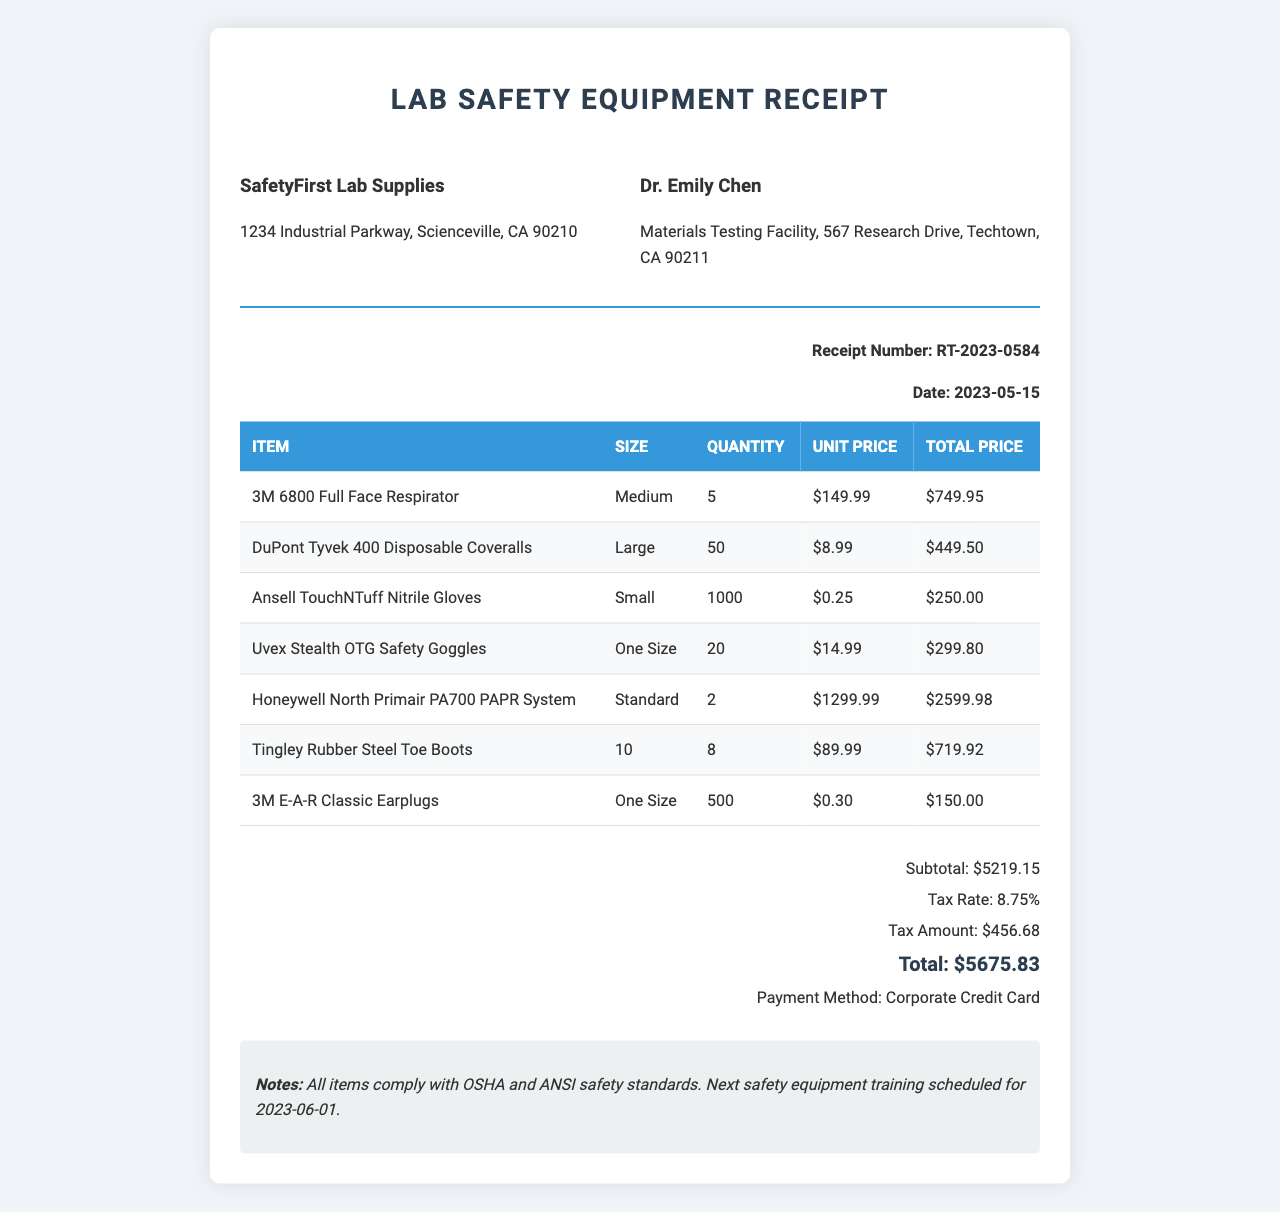What is the receipt number? The receipt number is clearly stated in the document, labeled accordingly.
Answer: RT-2023-0584 What is the date of purchase? The date of purchase is mentioned explicitly in the receipt details.
Answer: 2023-05-15 Who is the customer? The customer name is indicated in the customer information section of the document.
Answer: Dr. Emily Chen How many 3M 6800 Full Face Respirators were purchased? The quantity of this item is given in the items list of the receipt.
Answer: 5 What is the total amount including tax? The total is calculated as the sum of the subtotal and tax amount listed at the end of the document.
Answer: 5675.83 What is the subtotal before tax? The subtotal can be found in the totals section of the document, indicating the cost before tax.
Answer: 5219.15 How many Disposable Coveralls were ordered? The quantity of DuPont Tyvek 400 Disposable Coveralls is specified in the items list.
Answer: 50 Which payment method was used? The payment method is clearly mentioned in the totals section towards the end of the document.
Answer: Corporate Credit Card What is the tax rate applied to the purchase? The tax rate is explicitly noted in the totals section of the receipt.
Answer: 8.75% 